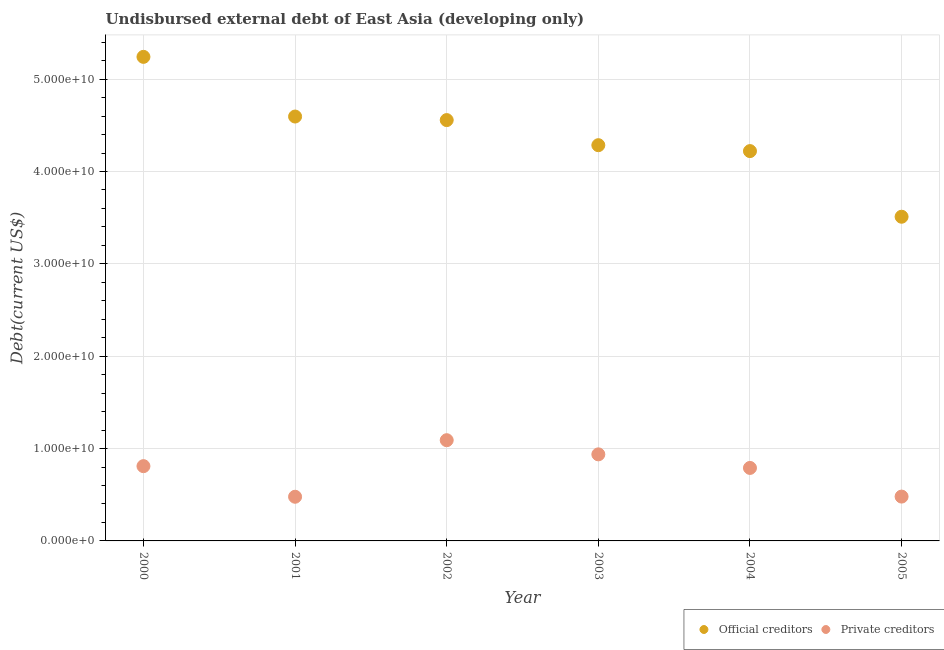How many different coloured dotlines are there?
Provide a succinct answer. 2. What is the undisbursed external debt of private creditors in 2005?
Your answer should be compact. 4.80e+09. Across all years, what is the maximum undisbursed external debt of official creditors?
Give a very brief answer. 5.24e+1. Across all years, what is the minimum undisbursed external debt of official creditors?
Offer a terse response. 3.51e+1. In which year was the undisbursed external debt of official creditors maximum?
Your response must be concise. 2000. In which year was the undisbursed external debt of official creditors minimum?
Make the answer very short. 2005. What is the total undisbursed external debt of private creditors in the graph?
Offer a terse response. 4.59e+1. What is the difference between the undisbursed external debt of official creditors in 2000 and that in 2001?
Give a very brief answer. 6.46e+09. What is the difference between the undisbursed external debt of private creditors in 2003 and the undisbursed external debt of official creditors in 2004?
Make the answer very short. -3.28e+1. What is the average undisbursed external debt of private creditors per year?
Your answer should be compact. 7.64e+09. In the year 2000, what is the difference between the undisbursed external debt of private creditors and undisbursed external debt of official creditors?
Give a very brief answer. -4.43e+1. What is the ratio of the undisbursed external debt of official creditors in 2002 to that in 2003?
Keep it short and to the point. 1.06. Is the undisbursed external debt of private creditors in 2000 less than that in 2004?
Your answer should be very brief. No. What is the difference between the highest and the second highest undisbursed external debt of official creditors?
Provide a succinct answer. 6.46e+09. What is the difference between the highest and the lowest undisbursed external debt of official creditors?
Provide a succinct answer. 1.73e+1. In how many years, is the undisbursed external debt of private creditors greater than the average undisbursed external debt of private creditors taken over all years?
Offer a very short reply. 4. Is the undisbursed external debt of private creditors strictly greater than the undisbursed external debt of official creditors over the years?
Provide a succinct answer. No. Is the undisbursed external debt of official creditors strictly less than the undisbursed external debt of private creditors over the years?
Keep it short and to the point. No. How many dotlines are there?
Your answer should be very brief. 2. Are the values on the major ticks of Y-axis written in scientific E-notation?
Keep it short and to the point. Yes. Does the graph contain grids?
Ensure brevity in your answer.  Yes. How are the legend labels stacked?
Your answer should be compact. Horizontal. What is the title of the graph?
Offer a terse response. Undisbursed external debt of East Asia (developing only). What is the label or title of the X-axis?
Provide a succinct answer. Year. What is the label or title of the Y-axis?
Your answer should be compact. Debt(current US$). What is the Debt(current US$) in Official creditors in 2000?
Offer a very short reply. 5.24e+1. What is the Debt(current US$) of Private creditors in 2000?
Ensure brevity in your answer.  8.10e+09. What is the Debt(current US$) of Official creditors in 2001?
Your response must be concise. 4.60e+1. What is the Debt(current US$) in Private creditors in 2001?
Make the answer very short. 4.78e+09. What is the Debt(current US$) of Official creditors in 2002?
Give a very brief answer. 4.56e+1. What is the Debt(current US$) of Private creditors in 2002?
Keep it short and to the point. 1.09e+1. What is the Debt(current US$) in Official creditors in 2003?
Your answer should be compact. 4.28e+1. What is the Debt(current US$) in Private creditors in 2003?
Provide a short and direct response. 9.37e+09. What is the Debt(current US$) in Official creditors in 2004?
Give a very brief answer. 4.22e+1. What is the Debt(current US$) in Private creditors in 2004?
Offer a terse response. 7.90e+09. What is the Debt(current US$) of Official creditors in 2005?
Offer a very short reply. 3.51e+1. What is the Debt(current US$) in Private creditors in 2005?
Keep it short and to the point. 4.80e+09. Across all years, what is the maximum Debt(current US$) in Official creditors?
Offer a very short reply. 5.24e+1. Across all years, what is the maximum Debt(current US$) of Private creditors?
Offer a very short reply. 1.09e+1. Across all years, what is the minimum Debt(current US$) of Official creditors?
Provide a short and direct response. 3.51e+1. Across all years, what is the minimum Debt(current US$) of Private creditors?
Provide a short and direct response. 4.78e+09. What is the total Debt(current US$) in Official creditors in the graph?
Keep it short and to the point. 2.64e+11. What is the total Debt(current US$) in Private creditors in the graph?
Your response must be concise. 4.59e+1. What is the difference between the Debt(current US$) of Official creditors in 2000 and that in 2001?
Your response must be concise. 6.46e+09. What is the difference between the Debt(current US$) of Private creditors in 2000 and that in 2001?
Provide a short and direct response. 3.31e+09. What is the difference between the Debt(current US$) in Official creditors in 2000 and that in 2002?
Ensure brevity in your answer.  6.85e+09. What is the difference between the Debt(current US$) in Private creditors in 2000 and that in 2002?
Give a very brief answer. -2.81e+09. What is the difference between the Debt(current US$) in Official creditors in 2000 and that in 2003?
Your response must be concise. 9.56e+09. What is the difference between the Debt(current US$) of Private creditors in 2000 and that in 2003?
Your answer should be very brief. -1.28e+09. What is the difference between the Debt(current US$) of Official creditors in 2000 and that in 2004?
Keep it short and to the point. 1.02e+1. What is the difference between the Debt(current US$) in Private creditors in 2000 and that in 2004?
Offer a very short reply. 1.93e+08. What is the difference between the Debt(current US$) of Official creditors in 2000 and that in 2005?
Offer a terse response. 1.73e+1. What is the difference between the Debt(current US$) of Private creditors in 2000 and that in 2005?
Provide a short and direct response. 3.30e+09. What is the difference between the Debt(current US$) in Official creditors in 2001 and that in 2002?
Provide a succinct answer. 3.85e+08. What is the difference between the Debt(current US$) in Private creditors in 2001 and that in 2002?
Keep it short and to the point. -6.12e+09. What is the difference between the Debt(current US$) of Official creditors in 2001 and that in 2003?
Provide a short and direct response. 3.10e+09. What is the difference between the Debt(current US$) in Private creditors in 2001 and that in 2003?
Keep it short and to the point. -4.59e+09. What is the difference between the Debt(current US$) in Official creditors in 2001 and that in 2004?
Give a very brief answer. 3.74e+09. What is the difference between the Debt(current US$) in Private creditors in 2001 and that in 2004?
Offer a very short reply. -3.12e+09. What is the difference between the Debt(current US$) in Official creditors in 2001 and that in 2005?
Ensure brevity in your answer.  1.08e+1. What is the difference between the Debt(current US$) in Private creditors in 2001 and that in 2005?
Make the answer very short. -1.77e+07. What is the difference between the Debt(current US$) in Official creditors in 2002 and that in 2003?
Give a very brief answer. 2.72e+09. What is the difference between the Debt(current US$) of Private creditors in 2002 and that in 2003?
Keep it short and to the point. 1.53e+09. What is the difference between the Debt(current US$) of Official creditors in 2002 and that in 2004?
Your answer should be compact. 3.36e+09. What is the difference between the Debt(current US$) of Private creditors in 2002 and that in 2004?
Ensure brevity in your answer.  3.00e+09. What is the difference between the Debt(current US$) in Official creditors in 2002 and that in 2005?
Provide a short and direct response. 1.05e+1. What is the difference between the Debt(current US$) of Private creditors in 2002 and that in 2005?
Offer a very short reply. 6.11e+09. What is the difference between the Debt(current US$) in Official creditors in 2003 and that in 2004?
Give a very brief answer. 6.40e+08. What is the difference between the Debt(current US$) of Private creditors in 2003 and that in 2004?
Provide a short and direct response. 1.47e+09. What is the difference between the Debt(current US$) in Official creditors in 2003 and that in 2005?
Make the answer very short. 7.75e+09. What is the difference between the Debt(current US$) in Private creditors in 2003 and that in 2005?
Offer a terse response. 4.57e+09. What is the difference between the Debt(current US$) of Official creditors in 2004 and that in 2005?
Give a very brief answer. 7.11e+09. What is the difference between the Debt(current US$) of Private creditors in 2004 and that in 2005?
Keep it short and to the point. 3.10e+09. What is the difference between the Debt(current US$) of Official creditors in 2000 and the Debt(current US$) of Private creditors in 2001?
Ensure brevity in your answer.  4.76e+1. What is the difference between the Debt(current US$) of Official creditors in 2000 and the Debt(current US$) of Private creditors in 2002?
Offer a very short reply. 4.15e+1. What is the difference between the Debt(current US$) of Official creditors in 2000 and the Debt(current US$) of Private creditors in 2003?
Provide a succinct answer. 4.30e+1. What is the difference between the Debt(current US$) of Official creditors in 2000 and the Debt(current US$) of Private creditors in 2004?
Your response must be concise. 4.45e+1. What is the difference between the Debt(current US$) of Official creditors in 2000 and the Debt(current US$) of Private creditors in 2005?
Ensure brevity in your answer.  4.76e+1. What is the difference between the Debt(current US$) of Official creditors in 2001 and the Debt(current US$) of Private creditors in 2002?
Offer a very short reply. 3.50e+1. What is the difference between the Debt(current US$) of Official creditors in 2001 and the Debt(current US$) of Private creditors in 2003?
Provide a succinct answer. 3.66e+1. What is the difference between the Debt(current US$) in Official creditors in 2001 and the Debt(current US$) in Private creditors in 2004?
Offer a very short reply. 3.80e+1. What is the difference between the Debt(current US$) in Official creditors in 2001 and the Debt(current US$) in Private creditors in 2005?
Keep it short and to the point. 4.12e+1. What is the difference between the Debt(current US$) of Official creditors in 2002 and the Debt(current US$) of Private creditors in 2003?
Provide a succinct answer. 3.62e+1. What is the difference between the Debt(current US$) of Official creditors in 2002 and the Debt(current US$) of Private creditors in 2004?
Provide a succinct answer. 3.77e+1. What is the difference between the Debt(current US$) in Official creditors in 2002 and the Debt(current US$) in Private creditors in 2005?
Offer a very short reply. 4.08e+1. What is the difference between the Debt(current US$) in Official creditors in 2003 and the Debt(current US$) in Private creditors in 2004?
Give a very brief answer. 3.49e+1. What is the difference between the Debt(current US$) of Official creditors in 2003 and the Debt(current US$) of Private creditors in 2005?
Your answer should be compact. 3.80e+1. What is the difference between the Debt(current US$) of Official creditors in 2004 and the Debt(current US$) of Private creditors in 2005?
Your answer should be compact. 3.74e+1. What is the average Debt(current US$) in Official creditors per year?
Your answer should be very brief. 4.40e+1. What is the average Debt(current US$) of Private creditors per year?
Your answer should be compact. 7.64e+09. In the year 2000, what is the difference between the Debt(current US$) of Official creditors and Debt(current US$) of Private creditors?
Your response must be concise. 4.43e+1. In the year 2001, what is the difference between the Debt(current US$) of Official creditors and Debt(current US$) of Private creditors?
Give a very brief answer. 4.12e+1. In the year 2002, what is the difference between the Debt(current US$) of Official creditors and Debt(current US$) of Private creditors?
Ensure brevity in your answer.  3.47e+1. In the year 2003, what is the difference between the Debt(current US$) of Official creditors and Debt(current US$) of Private creditors?
Ensure brevity in your answer.  3.35e+1. In the year 2004, what is the difference between the Debt(current US$) of Official creditors and Debt(current US$) of Private creditors?
Offer a terse response. 3.43e+1. In the year 2005, what is the difference between the Debt(current US$) of Official creditors and Debt(current US$) of Private creditors?
Your answer should be compact. 3.03e+1. What is the ratio of the Debt(current US$) in Official creditors in 2000 to that in 2001?
Offer a very short reply. 1.14. What is the ratio of the Debt(current US$) of Private creditors in 2000 to that in 2001?
Offer a terse response. 1.69. What is the ratio of the Debt(current US$) in Official creditors in 2000 to that in 2002?
Your response must be concise. 1.15. What is the ratio of the Debt(current US$) of Private creditors in 2000 to that in 2002?
Offer a terse response. 0.74. What is the ratio of the Debt(current US$) in Official creditors in 2000 to that in 2003?
Your answer should be very brief. 1.22. What is the ratio of the Debt(current US$) of Private creditors in 2000 to that in 2003?
Offer a terse response. 0.86. What is the ratio of the Debt(current US$) in Official creditors in 2000 to that in 2004?
Your answer should be very brief. 1.24. What is the ratio of the Debt(current US$) of Private creditors in 2000 to that in 2004?
Keep it short and to the point. 1.02. What is the ratio of the Debt(current US$) in Official creditors in 2000 to that in 2005?
Provide a succinct answer. 1.49. What is the ratio of the Debt(current US$) in Private creditors in 2000 to that in 2005?
Offer a very short reply. 1.69. What is the ratio of the Debt(current US$) of Official creditors in 2001 to that in 2002?
Ensure brevity in your answer.  1.01. What is the ratio of the Debt(current US$) in Private creditors in 2001 to that in 2002?
Provide a succinct answer. 0.44. What is the ratio of the Debt(current US$) in Official creditors in 2001 to that in 2003?
Your answer should be compact. 1.07. What is the ratio of the Debt(current US$) of Private creditors in 2001 to that in 2003?
Give a very brief answer. 0.51. What is the ratio of the Debt(current US$) of Official creditors in 2001 to that in 2004?
Your answer should be very brief. 1.09. What is the ratio of the Debt(current US$) in Private creditors in 2001 to that in 2004?
Offer a very short reply. 0.61. What is the ratio of the Debt(current US$) in Official creditors in 2001 to that in 2005?
Offer a very short reply. 1.31. What is the ratio of the Debt(current US$) in Private creditors in 2001 to that in 2005?
Ensure brevity in your answer.  1. What is the ratio of the Debt(current US$) of Official creditors in 2002 to that in 2003?
Provide a short and direct response. 1.06. What is the ratio of the Debt(current US$) of Private creditors in 2002 to that in 2003?
Your answer should be compact. 1.16. What is the ratio of the Debt(current US$) in Official creditors in 2002 to that in 2004?
Give a very brief answer. 1.08. What is the ratio of the Debt(current US$) of Private creditors in 2002 to that in 2004?
Your answer should be compact. 1.38. What is the ratio of the Debt(current US$) in Official creditors in 2002 to that in 2005?
Your answer should be compact. 1.3. What is the ratio of the Debt(current US$) of Private creditors in 2002 to that in 2005?
Ensure brevity in your answer.  2.27. What is the ratio of the Debt(current US$) in Official creditors in 2003 to that in 2004?
Provide a short and direct response. 1.02. What is the ratio of the Debt(current US$) in Private creditors in 2003 to that in 2004?
Ensure brevity in your answer.  1.19. What is the ratio of the Debt(current US$) in Official creditors in 2003 to that in 2005?
Offer a very short reply. 1.22. What is the ratio of the Debt(current US$) in Private creditors in 2003 to that in 2005?
Provide a short and direct response. 1.95. What is the ratio of the Debt(current US$) in Official creditors in 2004 to that in 2005?
Make the answer very short. 1.2. What is the ratio of the Debt(current US$) of Private creditors in 2004 to that in 2005?
Provide a short and direct response. 1.65. What is the difference between the highest and the second highest Debt(current US$) in Official creditors?
Provide a succinct answer. 6.46e+09. What is the difference between the highest and the second highest Debt(current US$) of Private creditors?
Your answer should be very brief. 1.53e+09. What is the difference between the highest and the lowest Debt(current US$) of Official creditors?
Provide a short and direct response. 1.73e+1. What is the difference between the highest and the lowest Debt(current US$) of Private creditors?
Provide a short and direct response. 6.12e+09. 